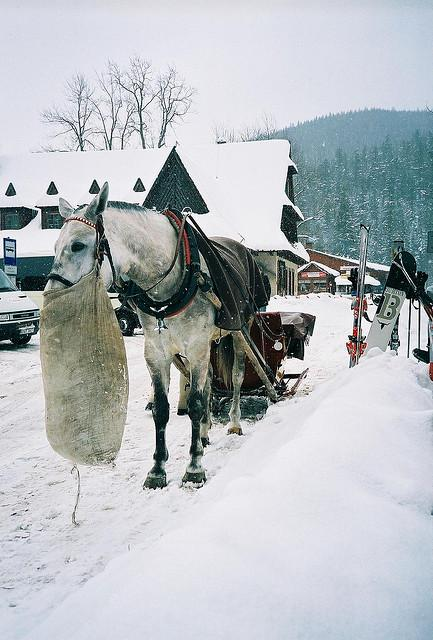The animal has how many legs? Please explain your reasoning. four. The animal has 4 legs. 